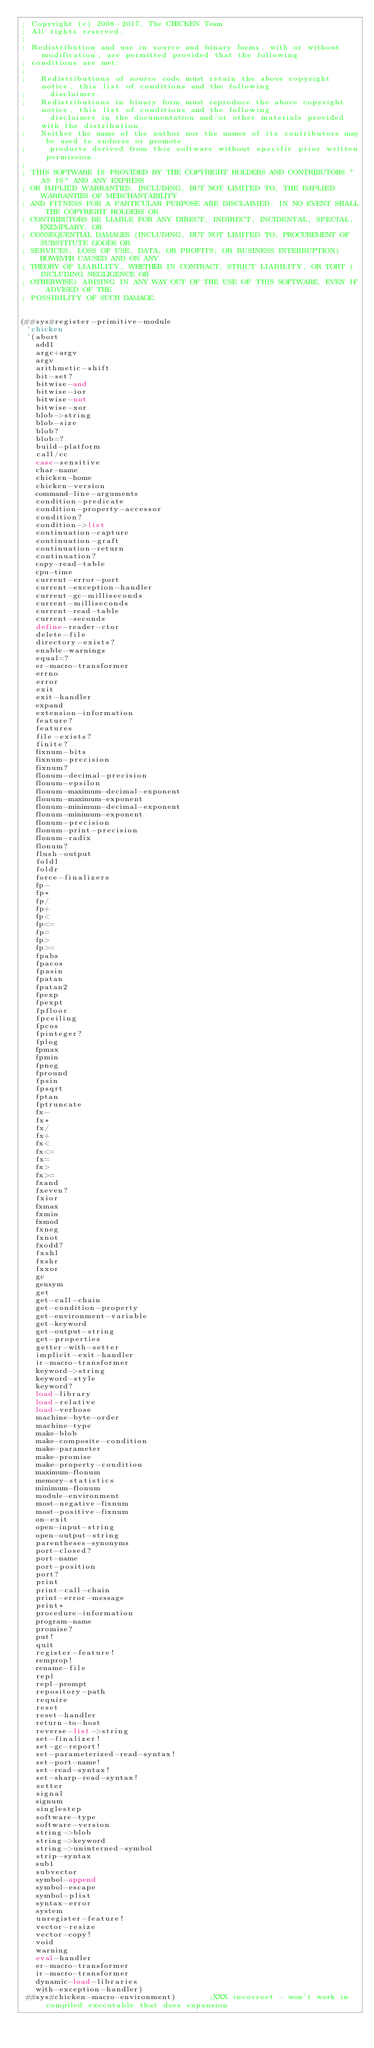Convert code to text. <code><loc_0><loc_0><loc_500><loc_500><_Scheme_>; Copyright (c) 2008-2017, The CHICKEN Team
; All rights reserved.
;
; Redistribution and use in source and binary forms, with or without modification, are permitted provided that the following
; conditions are met:
;
;   Redistributions of source code must retain the above copyright notice, this list of conditions and the following
;     disclaimer.
;   Redistributions in binary form must reproduce the above copyright notice, this list of conditions and the following
;     disclaimer in the documentation and/or other materials provided with the distribution.
;   Neither the name of the author nor the names of its contributors may be used to endorse or promote
;     products derived from this software without specific prior written permission.
;
; THIS SOFTWARE IS PROVIDED BY THE COPYRIGHT HOLDERS AND CONTRIBUTORS "AS IS" AND ANY EXPRESS
; OR IMPLIED WARRANTIES, INCLUDING, BUT NOT LIMITED TO, THE IMPLIED WARRANTIES OF MERCHANTABILITY
; AND FITNESS FOR A PARTICULAR PURPOSE ARE DISCLAIMED. IN NO EVENT SHALL THE COPYRIGHT HOLDERS OR
; CONTRIBUTORS BE LIABLE FOR ANY DIRECT, INDIRECT, INCIDENTAL, SPECIAL, EXEMPLARY, OR
; CONSEQUENTIAL DAMAGES (INCLUDING, BUT NOT LIMITED TO, PROCUREMENT OF SUBSTITUTE GOODS OR
; SERVICES; LOSS OF USE, DATA, OR PROFITS; OR BUSINESS INTERRUPTION) HOWEVER CAUSED AND ON ANY
; THEORY OF LIABILITY, WHETHER IN CONTRACT, STRICT LIABILITY, OR TORT (INCLUDING NEGLIGENCE OR
; OTHERWISE) ARISING IN ANY WAY OUT OF THE USE OF THIS SOFTWARE, EVEN IF ADVISED OF THE
; POSSIBILITY OF SUCH DAMAGE.


(##sys#register-primitive-module
 'chicken
 '(abort
   add1
   argc+argv
   argv
   arithmetic-shift
   bit-set?
   bitwise-and
   bitwise-ior
   bitwise-not
   bitwise-xor
   blob->string
   blob-size
   blob?
   blob=?
   build-platform
   call/cc
   case-sensitive
   char-name
   chicken-home
   chicken-version
   command-line-arguments
   condition-predicate
   condition-property-accessor
   condition?
   condition->list
   continuation-capture
   continuation-graft
   continuation-return
   continuation?
   copy-read-table
   cpu-time
   current-error-port
   current-exception-handler
   current-gc-milliseconds
   current-milliseconds
   current-read-table
   current-seconds
   define-reader-ctor
   delete-file
   directory-exists?
   enable-warnings
   equal=?
   er-macro-transformer
   errno
   error
   exit
   exit-handler
   expand
   extension-information
   feature?
   features
   file-exists?
   finite?
   fixnum-bits
   fixnum-precision
   fixnum?
   flonum-decimal-precision
   flonum-epsilon
   flonum-maximum-decimal-exponent
   flonum-maximum-exponent
   flonum-minimum-decimal-exponent
   flonum-minimum-exponent
   flonum-precision
   flonum-print-precision
   flonum-radix
   flonum?
   flush-output
   foldl
   foldr
   force-finalizers
   fp-
   fp*
   fp/
   fp+
   fp<
   fp<=
   fp=
   fp>
   fp>=
   fpabs
   fpacos
   fpasin
   fpatan
   fpatan2
   fpexp
   fpexpt
   fpfloor
   fpceiling
   fpcos
   fpinteger?
   fplog
   fpmax
   fpmin
   fpneg
   fpround
   fpsin
   fpsqrt
   fptan
   fptruncate
   fx-
   fx*
   fx/
   fx+
   fx<
   fx<=
   fx=
   fx>
   fx>=
   fxand
   fxeven?
   fxior
   fxmax
   fxmin
   fxmod
   fxneg
   fxnot
   fxodd?
   fxshl
   fxshr
   fxxor
   gc
   gensym
   get
   get-call-chain
   get-condition-property
   get-environment-variable
   get-keyword
   get-output-string
   get-properties
   getter-with-setter
   implicit-exit-handler
   ir-macro-transformer
   keyword->string
   keyword-style
   keyword?
   load-library
   load-relative
   load-verbose
   machine-byte-order
   machine-type
   make-blob
   make-composite-condition
   make-parameter
   make-promise
   make-property-condition
   maximum-flonum
   memory-statistics
   minimum-flonum
   module-environment
   most-negative-fixnum
   most-positive-fixnum
   on-exit
   open-input-string
   open-output-string
   parentheses-synonyms
   port-closed?
   port-name
   port-position
   port?
   print
   print-call-chain
   print-error-message
   print*
   procedure-information
   program-name
   promise?
   put!
   quit
   register-feature!
   remprop!
   rename-file
   repl
   repl-prompt
   repository-path
   require
   reset
   reset-handler
   return-to-host
   reverse-list->string
   set-finalizer!
   set-gc-report!
   set-parameterized-read-syntax!
   set-port-name!
   set-read-syntax!
   set-sharp-read-syntax!
   setter
   signal
   signum
   singlestep
   software-type
   software-version
   string->blob
   string->keyword
   string->uninterned-symbol
   strip-syntax
   sub1
   subvector
   symbol-append
   symbol-escape
   symbol-plist
   syntax-error
   system
   unregister-feature!
   vector-resize
   vector-copy!
   void
   warning
   eval-handler
   er-macro-transformer
   ir-macro-transformer
   dynamic-load-libraries
   with-exception-handler)
 ##sys#chicken-macro-environment)       ;XXX incorrect - won't work in compiled executable that does expansion
</code> 